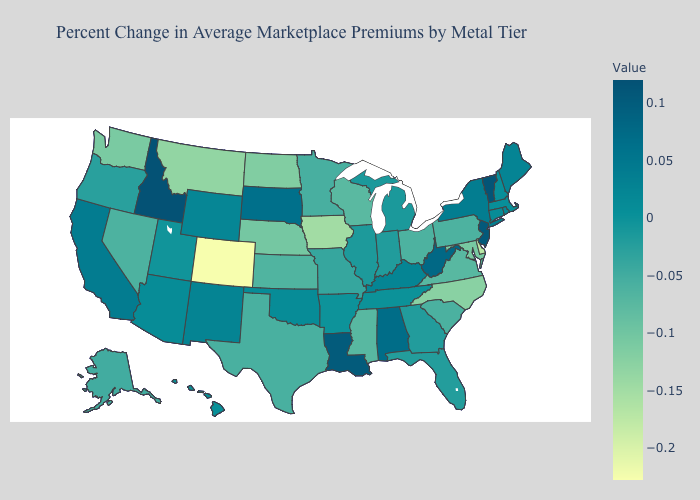Which states have the highest value in the USA?
Concise answer only. Idaho. Does Missouri have the highest value in the MidWest?
Be succinct. No. Does Washington have a lower value than Delaware?
Short answer required. No. Does the map have missing data?
Quick response, please. No. Does Oklahoma have a higher value than West Virginia?
Concise answer only. No. Which states have the highest value in the USA?
Quick response, please. Idaho. Among the states that border Oklahoma , does New Mexico have the highest value?
Give a very brief answer. Yes. Which states have the highest value in the USA?
Concise answer only. Idaho. Does Wyoming have the lowest value in the USA?
Short answer required. No. Which states have the highest value in the USA?
Give a very brief answer. Idaho. 